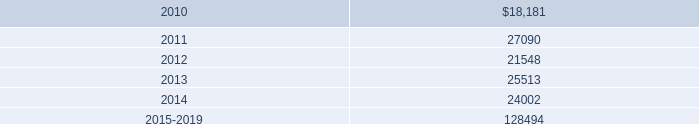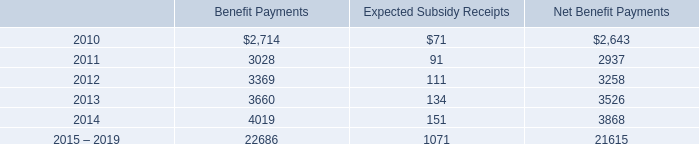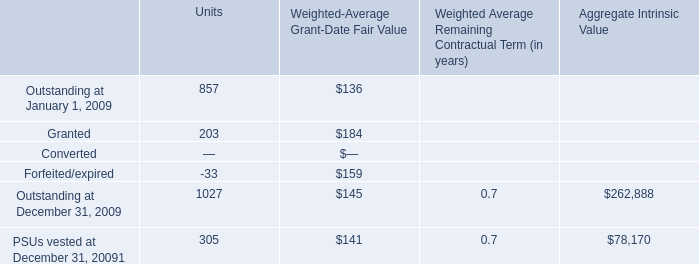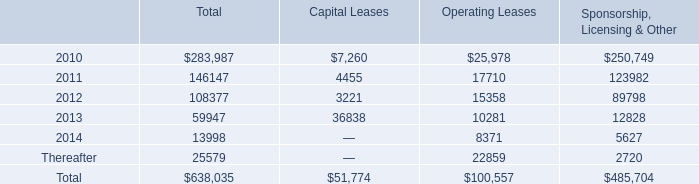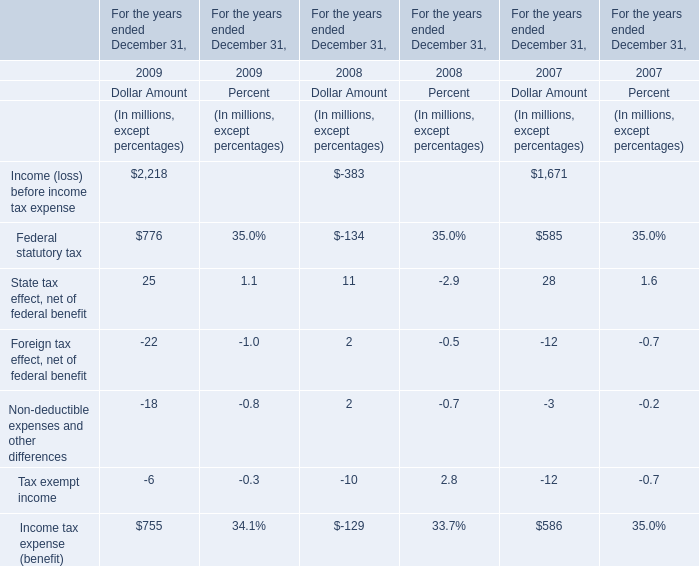What is the difference between the greatest Federal statutory tax in 2008 and 2009？ (in million) 
Computations: (2 - -22)
Answer: 24.0. 